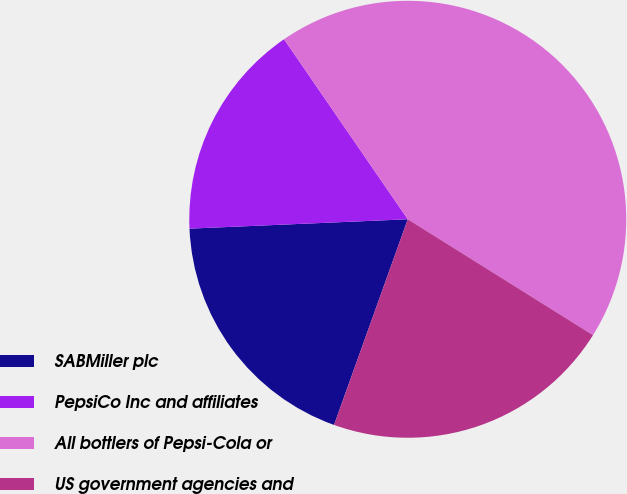Convert chart to OTSL. <chart><loc_0><loc_0><loc_500><loc_500><pie_chart><fcel>SABMiller plc<fcel>PepsiCo Inc and affiliates<fcel>All bottlers of Pepsi-Cola or<fcel>US government agencies and<nl><fcel>18.84%<fcel>16.1%<fcel>43.48%<fcel>21.58%<nl></chart> 